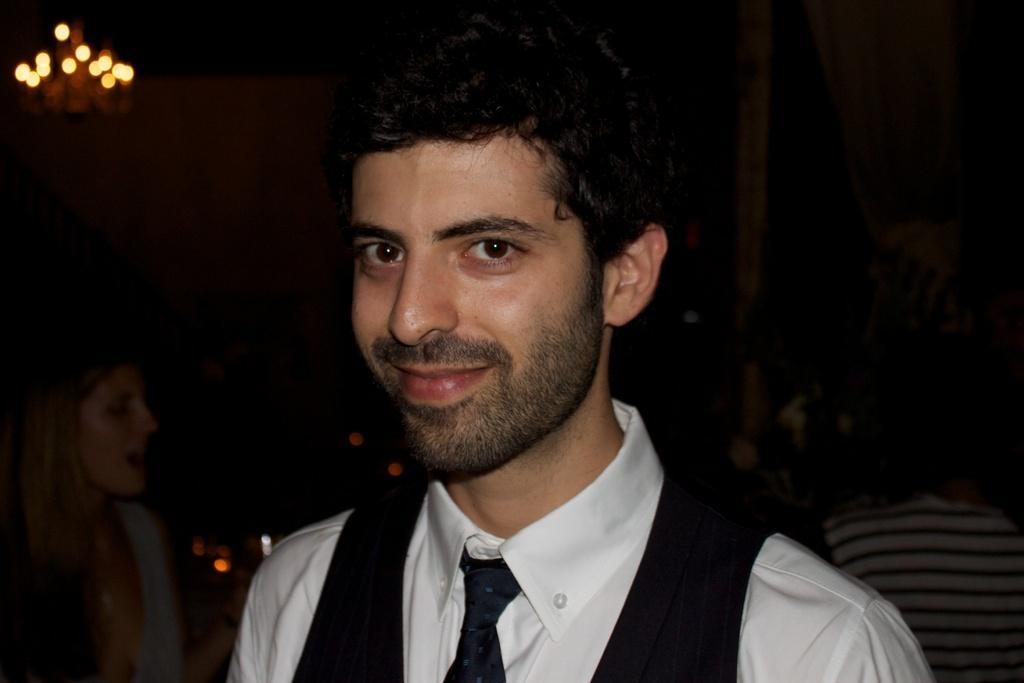Please provide a concise description of this image. This is the man standing and smiling. I can see a woman and a person standing. This looks like a light. I think this is a pole. 